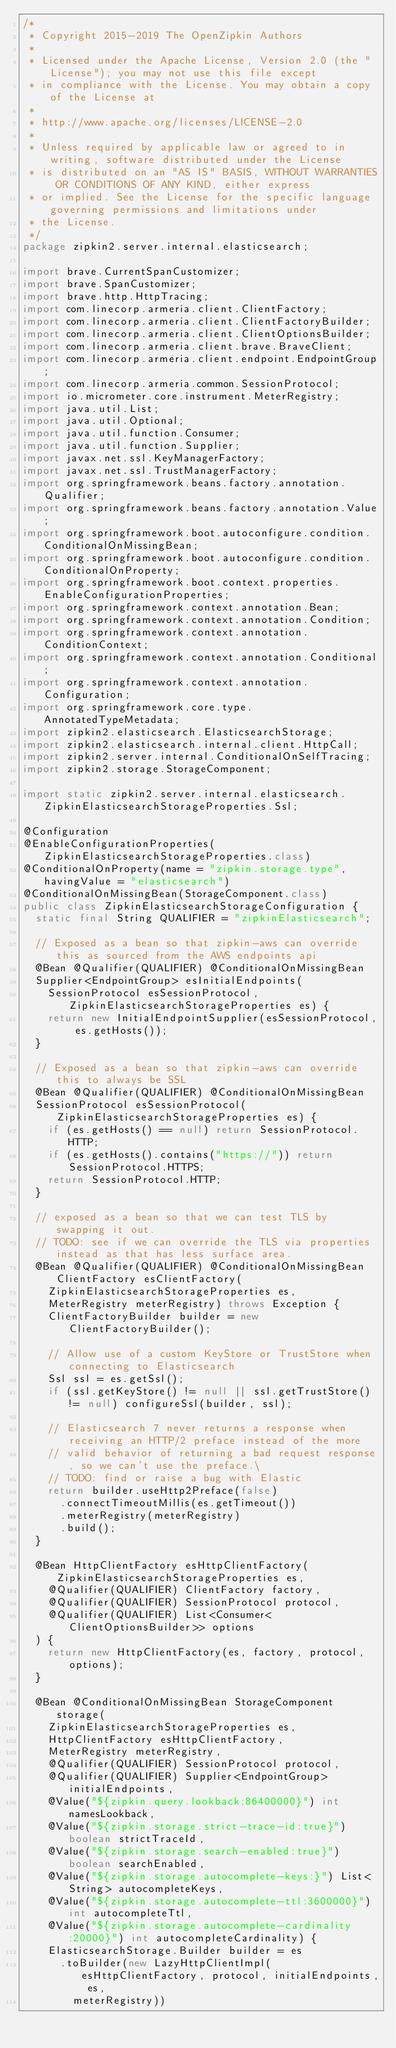<code> <loc_0><loc_0><loc_500><loc_500><_Java_>/*
 * Copyright 2015-2019 The OpenZipkin Authors
 *
 * Licensed under the Apache License, Version 2.0 (the "License"); you may not use this file except
 * in compliance with the License. You may obtain a copy of the License at
 *
 * http://www.apache.org/licenses/LICENSE-2.0
 *
 * Unless required by applicable law or agreed to in writing, software distributed under the License
 * is distributed on an "AS IS" BASIS, WITHOUT WARRANTIES OR CONDITIONS OF ANY KIND, either express
 * or implied. See the License for the specific language governing permissions and limitations under
 * the License.
 */
package zipkin2.server.internal.elasticsearch;

import brave.CurrentSpanCustomizer;
import brave.SpanCustomizer;
import brave.http.HttpTracing;
import com.linecorp.armeria.client.ClientFactory;
import com.linecorp.armeria.client.ClientFactoryBuilder;
import com.linecorp.armeria.client.ClientOptionsBuilder;
import com.linecorp.armeria.client.brave.BraveClient;
import com.linecorp.armeria.client.endpoint.EndpointGroup;
import com.linecorp.armeria.common.SessionProtocol;
import io.micrometer.core.instrument.MeterRegistry;
import java.util.List;
import java.util.Optional;
import java.util.function.Consumer;
import java.util.function.Supplier;
import javax.net.ssl.KeyManagerFactory;
import javax.net.ssl.TrustManagerFactory;
import org.springframework.beans.factory.annotation.Qualifier;
import org.springframework.beans.factory.annotation.Value;
import org.springframework.boot.autoconfigure.condition.ConditionalOnMissingBean;
import org.springframework.boot.autoconfigure.condition.ConditionalOnProperty;
import org.springframework.boot.context.properties.EnableConfigurationProperties;
import org.springframework.context.annotation.Bean;
import org.springframework.context.annotation.Condition;
import org.springframework.context.annotation.ConditionContext;
import org.springframework.context.annotation.Conditional;
import org.springframework.context.annotation.Configuration;
import org.springframework.core.type.AnnotatedTypeMetadata;
import zipkin2.elasticsearch.ElasticsearchStorage;
import zipkin2.elasticsearch.internal.client.HttpCall;
import zipkin2.server.internal.ConditionalOnSelfTracing;
import zipkin2.storage.StorageComponent;

import static zipkin2.server.internal.elasticsearch.ZipkinElasticsearchStorageProperties.Ssl;

@Configuration
@EnableConfigurationProperties(ZipkinElasticsearchStorageProperties.class)
@ConditionalOnProperty(name = "zipkin.storage.type", havingValue = "elasticsearch")
@ConditionalOnMissingBean(StorageComponent.class)
public class ZipkinElasticsearchStorageConfiguration {
  static final String QUALIFIER = "zipkinElasticsearch";

  // Exposed as a bean so that zipkin-aws can override this as sourced from the AWS endpoints api
  @Bean @Qualifier(QUALIFIER) @ConditionalOnMissingBean
  Supplier<EndpointGroup> esInitialEndpoints(
    SessionProtocol esSessionProtocol, ZipkinElasticsearchStorageProperties es) {
    return new InitialEndpointSupplier(esSessionProtocol, es.getHosts());
  }

  // Exposed as a bean so that zipkin-aws can override this to always be SSL
  @Bean @Qualifier(QUALIFIER) @ConditionalOnMissingBean
  SessionProtocol esSessionProtocol(ZipkinElasticsearchStorageProperties es) {
    if (es.getHosts() == null) return SessionProtocol.HTTP;
    if (es.getHosts().contains("https://")) return SessionProtocol.HTTPS;
    return SessionProtocol.HTTP;
  }

  // exposed as a bean so that we can test TLS by swapping it out.
  // TODO: see if we can override the TLS via properties instead as that has less surface area.
  @Bean @Qualifier(QUALIFIER) @ConditionalOnMissingBean ClientFactory esClientFactory(
    ZipkinElasticsearchStorageProperties es,
    MeterRegistry meterRegistry) throws Exception {
    ClientFactoryBuilder builder = new ClientFactoryBuilder();

    // Allow use of a custom KeyStore or TrustStore when connecting to Elasticsearch
    Ssl ssl = es.getSsl();
    if (ssl.getKeyStore() != null || ssl.getTrustStore() != null) configureSsl(builder, ssl);

    // Elasticsearch 7 never returns a response when receiving an HTTP/2 preface instead of the more
    // valid behavior of returning a bad request response, so we can't use the preface.\
    // TODO: find or raise a bug with Elastic
    return builder.useHttp2Preface(false)
      .connectTimeoutMillis(es.getTimeout())
      .meterRegistry(meterRegistry)
      .build();
  }

  @Bean HttpClientFactory esHttpClientFactory(ZipkinElasticsearchStorageProperties es,
    @Qualifier(QUALIFIER) ClientFactory factory,
    @Qualifier(QUALIFIER) SessionProtocol protocol,
    @Qualifier(QUALIFIER) List<Consumer<ClientOptionsBuilder>> options
  ) {
    return new HttpClientFactory(es, factory, protocol, options);
  }

  @Bean @ConditionalOnMissingBean StorageComponent storage(
    ZipkinElasticsearchStorageProperties es,
    HttpClientFactory esHttpClientFactory,
    MeterRegistry meterRegistry,
    @Qualifier(QUALIFIER) SessionProtocol protocol,
    @Qualifier(QUALIFIER) Supplier<EndpointGroup> initialEndpoints,
    @Value("${zipkin.query.lookback:86400000}") int namesLookback,
    @Value("${zipkin.storage.strict-trace-id:true}") boolean strictTraceId,
    @Value("${zipkin.storage.search-enabled:true}") boolean searchEnabled,
    @Value("${zipkin.storage.autocomplete-keys:}") List<String> autocompleteKeys,
    @Value("${zipkin.storage.autocomplete-ttl:3600000}") int autocompleteTtl,
    @Value("${zipkin.storage.autocomplete-cardinality:20000}") int autocompleteCardinality) {
    ElasticsearchStorage.Builder builder = es
      .toBuilder(new LazyHttpClientImpl(esHttpClientFactory, protocol, initialEndpoints, es,
        meterRegistry))</code> 